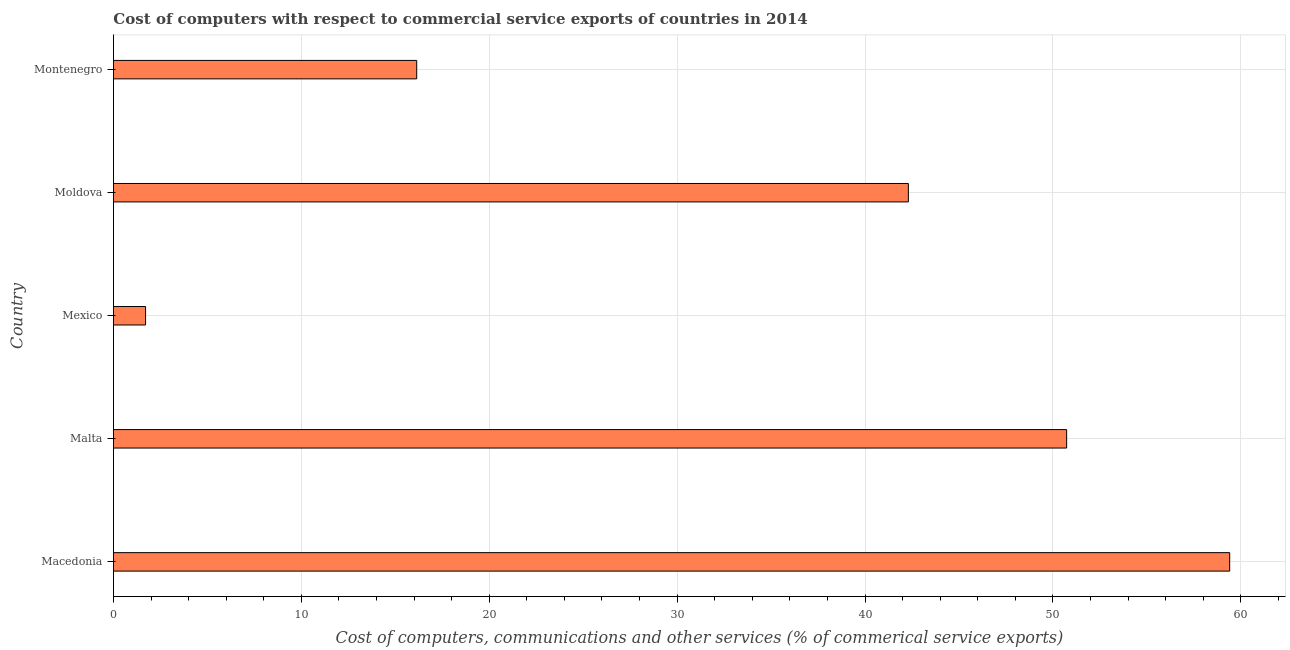Does the graph contain grids?
Offer a very short reply. Yes. What is the title of the graph?
Keep it short and to the point. Cost of computers with respect to commercial service exports of countries in 2014. What is the label or title of the X-axis?
Provide a short and direct response. Cost of computers, communications and other services (% of commerical service exports). What is the label or title of the Y-axis?
Provide a succinct answer. Country. What is the cost of communications in Mexico?
Your answer should be compact. 1.71. Across all countries, what is the maximum  computer and other services?
Your answer should be compact. 59.41. Across all countries, what is the minimum  computer and other services?
Keep it short and to the point. 1.71. In which country was the cost of communications maximum?
Ensure brevity in your answer.  Macedonia. What is the sum of the cost of communications?
Give a very brief answer. 170.29. What is the difference between the  computer and other services in Macedonia and Montenegro?
Keep it short and to the point. 43.27. What is the average cost of communications per country?
Your response must be concise. 34.06. What is the median cost of communications?
Ensure brevity in your answer.  42.31. In how many countries, is the cost of communications greater than 8 %?
Your response must be concise. 4. What is the ratio of the cost of communications in Macedonia to that in Montenegro?
Your answer should be very brief. 3.68. Is the  computer and other services in Malta less than that in Montenegro?
Your response must be concise. No. Is the difference between the  computer and other services in Malta and Moldova greater than the difference between any two countries?
Make the answer very short. No. What is the difference between the highest and the second highest cost of communications?
Offer a very short reply. 8.68. What is the difference between the highest and the lowest  computer and other services?
Provide a succinct answer. 57.7. In how many countries, is the cost of communications greater than the average cost of communications taken over all countries?
Your answer should be compact. 3. What is the difference between two consecutive major ticks on the X-axis?
Provide a succinct answer. 10. What is the Cost of computers, communications and other services (% of commerical service exports) of Macedonia?
Provide a short and direct response. 59.41. What is the Cost of computers, communications and other services (% of commerical service exports) in Malta?
Offer a terse response. 50.73. What is the Cost of computers, communications and other services (% of commerical service exports) of Mexico?
Give a very brief answer. 1.71. What is the Cost of computers, communications and other services (% of commerical service exports) of Moldova?
Make the answer very short. 42.31. What is the Cost of computers, communications and other services (% of commerical service exports) of Montenegro?
Your answer should be very brief. 16.14. What is the difference between the Cost of computers, communications and other services (% of commerical service exports) in Macedonia and Malta?
Give a very brief answer. 8.68. What is the difference between the Cost of computers, communications and other services (% of commerical service exports) in Macedonia and Mexico?
Ensure brevity in your answer.  57.7. What is the difference between the Cost of computers, communications and other services (% of commerical service exports) in Macedonia and Moldova?
Give a very brief answer. 17.1. What is the difference between the Cost of computers, communications and other services (% of commerical service exports) in Macedonia and Montenegro?
Your response must be concise. 43.27. What is the difference between the Cost of computers, communications and other services (% of commerical service exports) in Malta and Mexico?
Your response must be concise. 49.02. What is the difference between the Cost of computers, communications and other services (% of commerical service exports) in Malta and Moldova?
Ensure brevity in your answer.  8.42. What is the difference between the Cost of computers, communications and other services (% of commerical service exports) in Malta and Montenegro?
Offer a terse response. 34.59. What is the difference between the Cost of computers, communications and other services (% of commerical service exports) in Mexico and Moldova?
Your response must be concise. -40.6. What is the difference between the Cost of computers, communications and other services (% of commerical service exports) in Mexico and Montenegro?
Give a very brief answer. -14.43. What is the difference between the Cost of computers, communications and other services (% of commerical service exports) in Moldova and Montenegro?
Offer a terse response. 26.17. What is the ratio of the Cost of computers, communications and other services (% of commerical service exports) in Macedonia to that in Malta?
Offer a terse response. 1.17. What is the ratio of the Cost of computers, communications and other services (% of commerical service exports) in Macedonia to that in Mexico?
Your answer should be very brief. 34.8. What is the ratio of the Cost of computers, communications and other services (% of commerical service exports) in Macedonia to that in Moldova?
Your answer should be compact. 1.4. What is the ratio of the Cost of computers, communications and other services (% of commerical service exports) in Macedonia to that in Montenegro?
Make the answer very short. 3.68. What is the ratio of the Cost of computers, communications and other services (% of commerical service exports) in Malta to that in Mexico?
Your answer should be compact. 29.72. What is the ratio of the Cost of computers, communications and other services (% of commerical service exports) in Malta to that in Moldova?
Provide a short and direct response. 1.2. What is the ratio of the Cost of computers, communications and other services (% of commerical service exports) in Malta to that in Montenegro?
Make the answer very short. 3.14. What is the ratio of the Cost of computers, communications and other services (% of commerical service exports) in Mexico to that in Montenegro?
Provide a succinct answer. 0.11. What is the ratio of the Cost of computers, communications and other services (% of commerical service exports) in Moldova to that in Montenegro?
Provide a short and direct response. 2.62. 